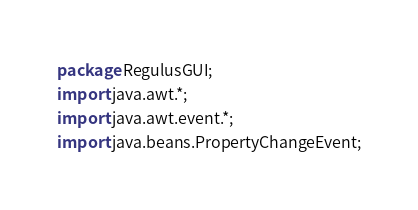<code> <loc_0><loc_0><loc_500><loc_500><_Java_>package RegulusGUI;
import java.awt.*;
import java.awt.event.*;
import java.beans.PropertyChangeEvent;</code> 